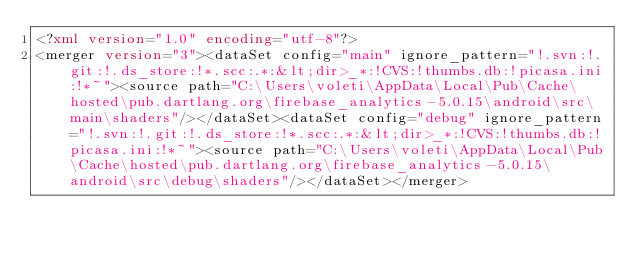<code> <loc_0><loc_0><loc_500><loc_500><_XML_><?xml version="1.0" encoding="utf-8"?>
<merger version="3"><dataSet config="main" ignore_pattern="!.svn:!.git:!.ds_store:!*.scc:.*:&lt;dir>_*:!CVS:!thumbs.db:!picasa.ini:!*~"><source path="C:\Users\voleti\AppData\Local\Pub\Cache\hosted\pub.dartlang.org\firebase_analytics-5.0.15\android\src\main\shaders"/></dataSet><dataSet config="debug" ignore_pattern="!.svn:!.git:!.ds_store:!*.scc:.*:&lt;dir>_*:!CVS:!thumbs.db:!picasa.ini:!*~"><source path="C:\Users\voleti\AppData\Local\Pub\Cache\hosted\pub.dartlang.org\firebase_analytics-5.0.15\android\src\debug\shaders"/></dataSet></merger></code> 